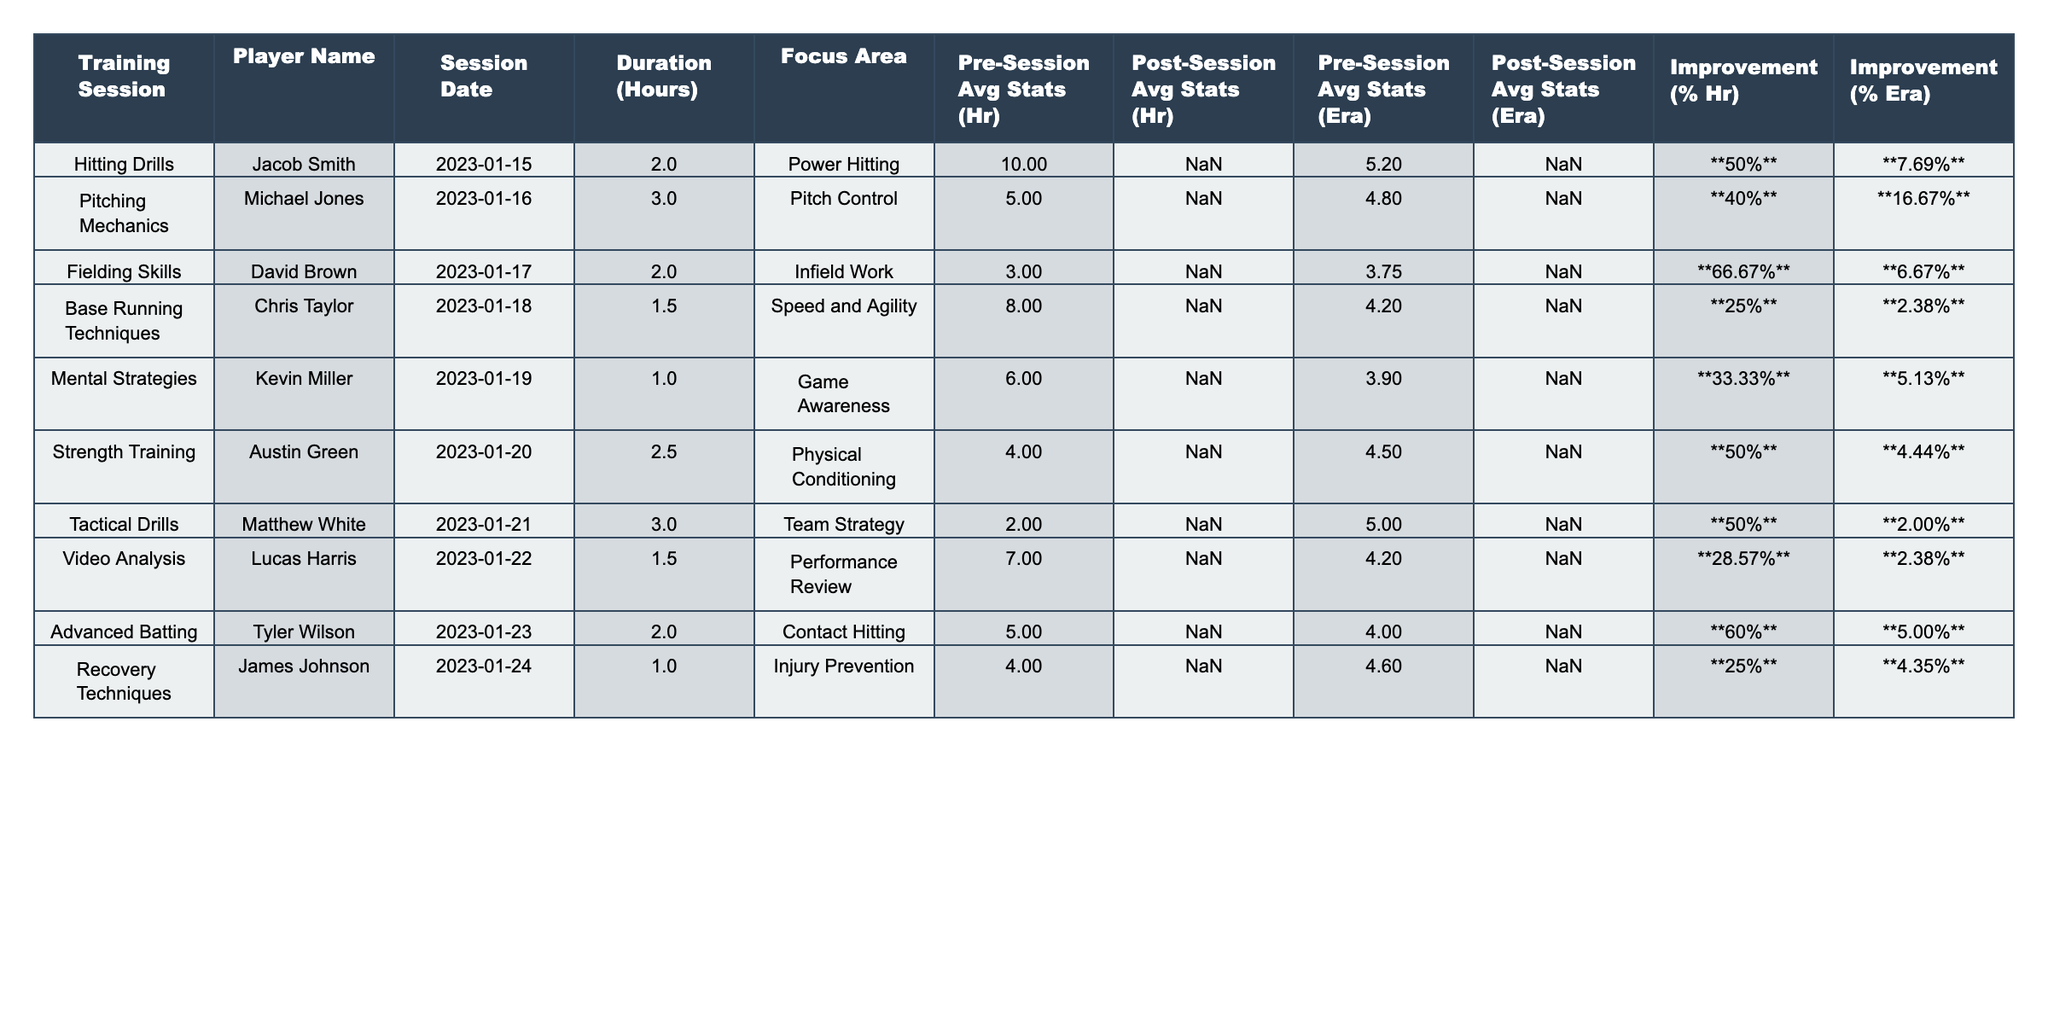What was the highest improvement percentage in home runs? From the table, Jacob Smith shows the highest improvement in home runs at **50%** after his training session.
Answer: 50% How many hours did Chris Taylor spend in his training session? The table indicates that Chris Taylor spent **1.5** hours in his training session focused on Speed and Agility.
Answer: 1.5 Did any player have a decrease in ERA after the training session? No players had a decrease in ERA; all showed improvements in their post-session ERA values compared to pre-session values.
Answer: No Which player had the best improvement in both home runs and ERA? David Brown had a **66.67%** improvement in home runs and a **6.67%** improvement in ERA, making his overall performance enhancement notable.
Answer: David Brown What is the average improvement in home runs across all players? Adding the improvements in home runs: 50% + 40% + 66.67% + 25% + 33.33% + 50% + 50% + 28.57% + 60% + 25% gives a total of approximately  409.57%. Dividing that by 10 (the number of players) gives an average of about **40.96%**.
Answer: 40.96% Who participated in multiple hours of training focusing on pitching mechanics? Michael Jones participated in **3** hours of training, focusing on pitch control, making him the player with the longest session in this category.
Answer: Michael Jones Which player retained the highest level of hitting average after the training? Tyler Wilson improved from **5** to **8** in home runs, showing that he maintained the highest post-session hitting average of **8**.
Answer: Tyler Wilson Was there a session that focused on tactical drills, and what was the improvement in home runs? Yes, the Tactical Drills session led by Matthew White showed a **50%** improvement in home runs post-training.
Answer: 50% Which player underwent training for injury prevention, and what was the improvement percentage in home runs? James Johnson underwent training for injury prevention and improved home runs by **25%** after his session.
Answer: 25% How many players showed an improvement in their ERA by more than 5%? Five players showed an improvement in their ERA by more than 5% based on the data presented in the table.
Answer: 5 